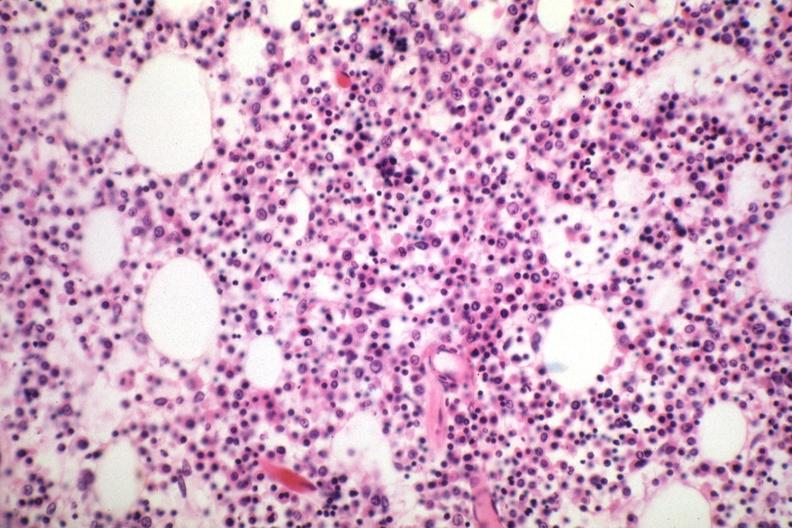what is marrow loaded?
Answer the question using a single word or phrase. With plasma cells that are immature 